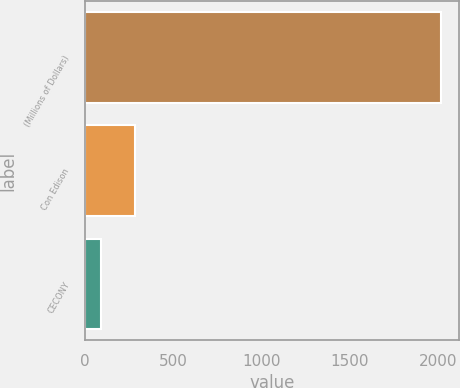<chart> <loc_0><loc_0><loc_500><loc_500><bar_chart><fcel>(Millions of Dollars)<fcel>Con Edison<fcel>CECONY<nl><fcel>2015<fcel>281.6<fcel>89<nl></chart> 